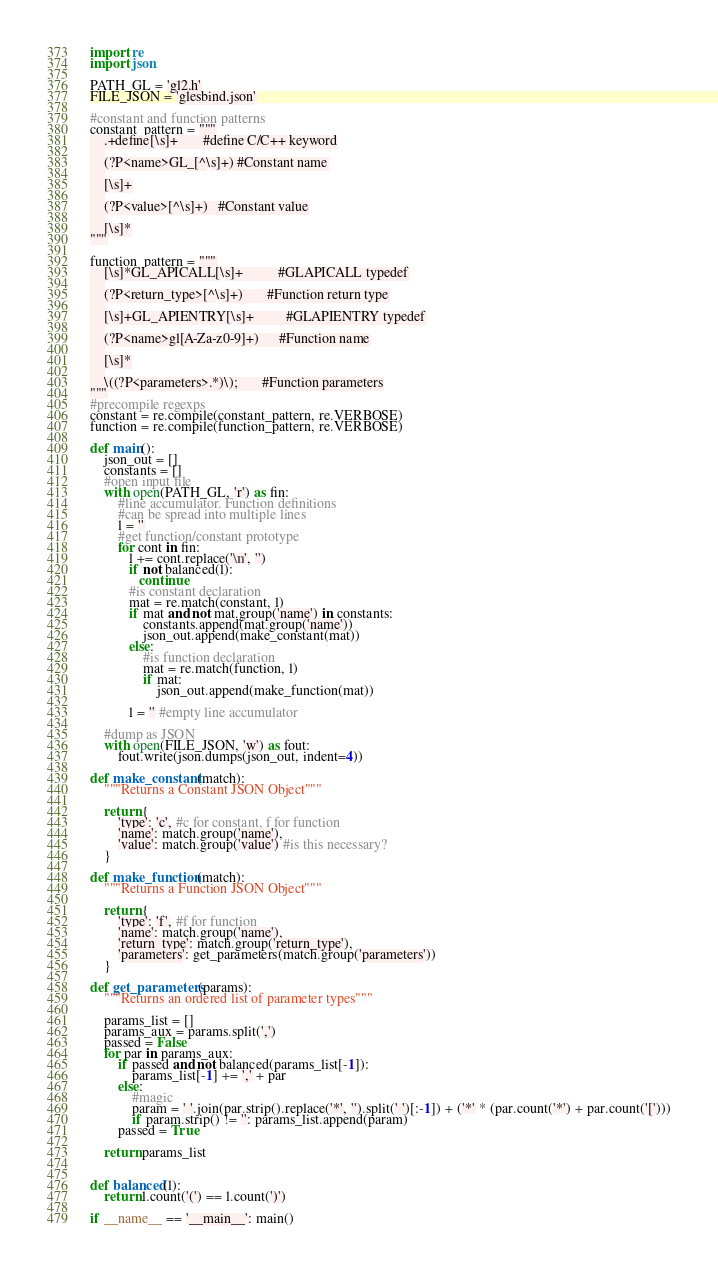<code> <loc_0><loc_0><loc_500><loc_500><_Python_>import re
import json

PATH_GL = 'gl2.h'
FILE_JSON = 'glesbind.json'

#constant and function patterns
constant_pattern = """
    .+define[\s]+       #define C/C++ keyword
    
    (?P<name>GL_[^\s]+) #Constant name
    
    [\s]+
    
    (?P<value>[^\s]+)   #Constant value
    
    [\s]*
"""

function_pattern = """
    [\s]*GL_APICALL[\s]+          #GLAPICALL typedef
    
    (?P<return_type>[^\s]+)       #Function return type
    
    [\s]+GL_APIENTRY[\s]+         #GLAPIENTRY typedef
    
    (?P<name>gl[A-Za-z0-9]+)      #Function name
    
    [\s]*
    
    \((?P<parameters>.*)\);       #Function parameters
"""
#precompile regexps
constant = re.compile(constant_pattern, re.VERBOSE)
function = re.compile(function_pattern, re.VERBOSE)

def main():
    json_out = []
    constants = []
    #open input file
    with open(PATH_GL, 'r') as fin:
        #line accumulator. Function definitions 
        #can be spread into multiple lines
        l = ''
        #get function/constant prototype
        for cont in fin:
           l += cont.replace('\n', '')
           if not balanced(l):
              continue
           #is constant declaration
           mat = re.match(constant, l)
           if mat and not mat.group('name') in constants:
               constants.append(mat.group('name'))
               json_out.append(make_constant(mat))
           else:
               #is function declaration
               mat = re.match(function, l)
               if mat: 
                   json_out.append(make_function(mat))
               
           l = '' #empty line accumulator

    #dump as JSON
    with open(FILE_JSON, 'w') as fout:
        fout.write(json.dumps(json_out, indent=4))

def make_constant(match):
    """Returns a Constant JSON Object"""
    
    return {
        'type': 'c', #c for constant, f for function
        'name': match.group('name'),
        'value': match.group('value') #is this necessary?        
    }

def make_function(match):
    """Returns a Function JSON Object"""
    
    return {
        'type': 'f', #f for function
        'name': match.group('name'),
        'return_type': match.group('return_type'),
        'parameters': get_parameters(match.group('parameters'))
    }

def get_parameters(params):
    """Returns an ordered list of parameter types"""
    
    params_list = []
    params_aux = params.split(',')
    passed = False
    for par in params_aux:
        if passed and not balanced(params_list[-1]):
            params_list[-1] += ',' + par
        else:
            #magic
            param = ' '.join(par.strip().replace('*', '').split(' ')[:-1]) + ('*' * (par.count('*') + par.count('[')))
            if param.strip() != '': params_list.append(param)
        passed = True
    
    return params_list


def balanced(l):
    return l.count('(') == l.count(')')

if __name__ == '__main__': main()</code> 